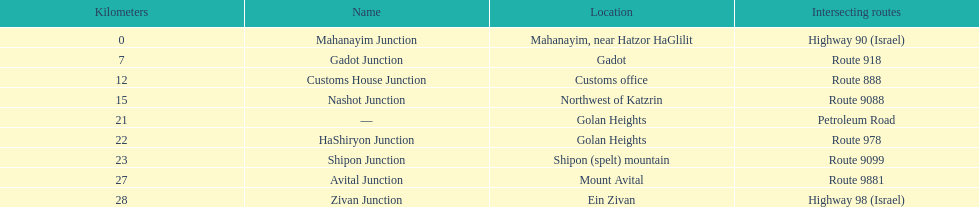What is the distance in kilometers to shipon junction? 23. What is the distance in kilometers to avital junction? 27. Which junction, shipon or avital, is nearer to nashot junction? Shipon Junction. 